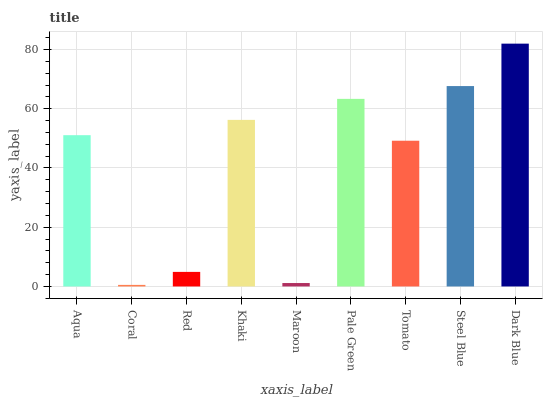Is Coral the minimum?
Answer yes or no. Yes. Is Dark Blue the maximum?
Answer yes or no. Yes. Is Red the minimum?
Answer yes or no. No. Is Red the maximum?
Answer yes or no. No. Is Red greater than Coral?
Answer yes or no. Yes. Is Coral less than Red?
Answer yes or no. Yes. Is Coral greater than Red?
Answer yes or no. No. Is Red less than Coral?
Answer yes or no. No. Is Aqua the high median?
Answer yes or no. Yes. Is Aqua the low median?
Answer yes or no. Yes. Is Pale Green the high median?
Answer yes or no. No. Is Coral the low median?
Answer yes or no. No. 